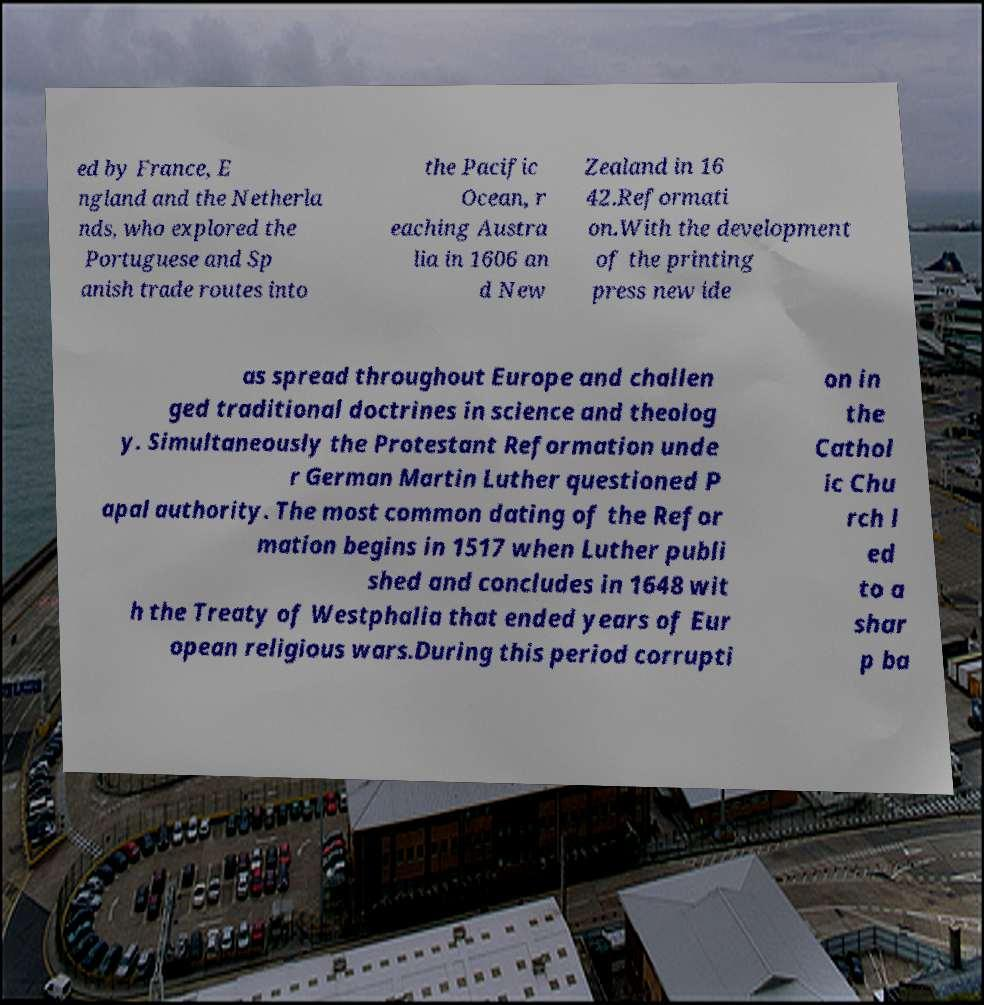For documentation purposes, I need the text within this image transcribed. Could you provide that? ed by France, E ngland and the Netherla nds, who explored the Portuguese and Sp anish trade routes into the Pacific Ocean, r eaching Austra lia in 1606 an d New Zealand in 16 42.Reformati on.With the development of the printing press new ide as spread throughout Europe and challen ged traditional doctrines in science and theolog y. Simultaneously the Protestant Reformation unde r German Martin Luther questioned P apal authority. The most common dating of the Refor mation begins in 1517 when Luther publi shed and concludes in 1648 wit h the Treaty of Westphalia that ended years of Eur opean religious wars.During this period corrupti on in the Cathol ic Chu rch l ed to a shar p ba 